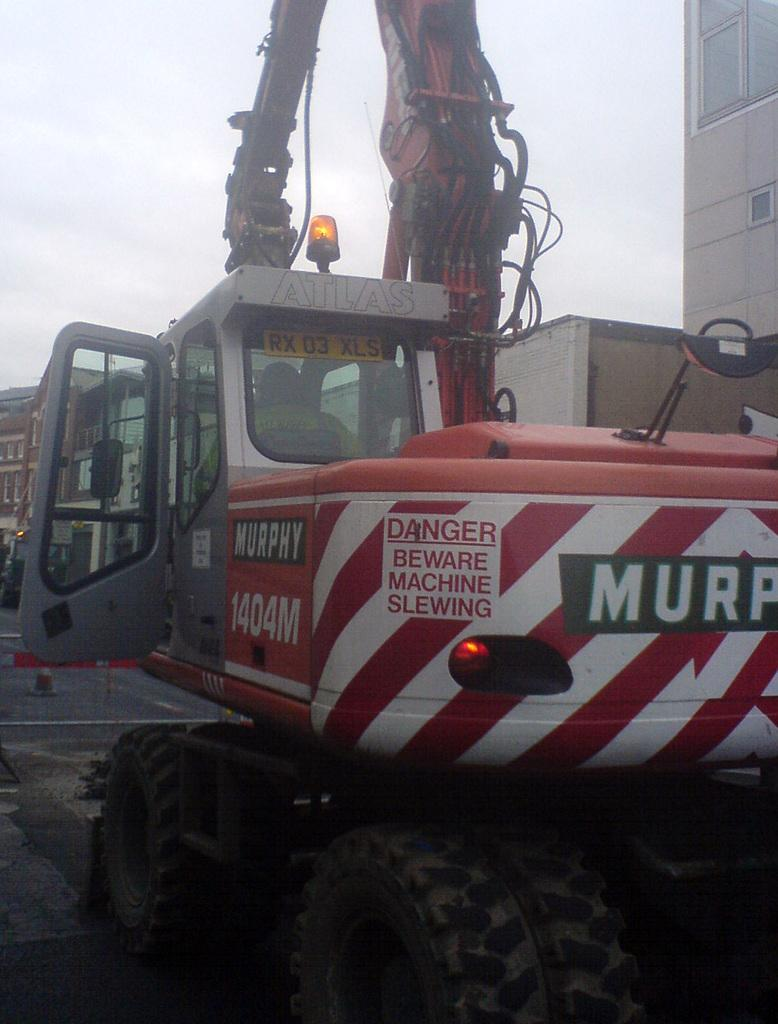What is the person in the image doing? There is a person sitting in a crane in the image. What can be seen in the background of the image? There are buildings in the background of the image. What is visible in the sky in the image? The sky is visible in the background of the image. What type of structure can be seen in the person's bedroom in the image? There is no bedroom or structure present in the image; it features a person sitting in a crane with buildings and the sky visible in the background. 